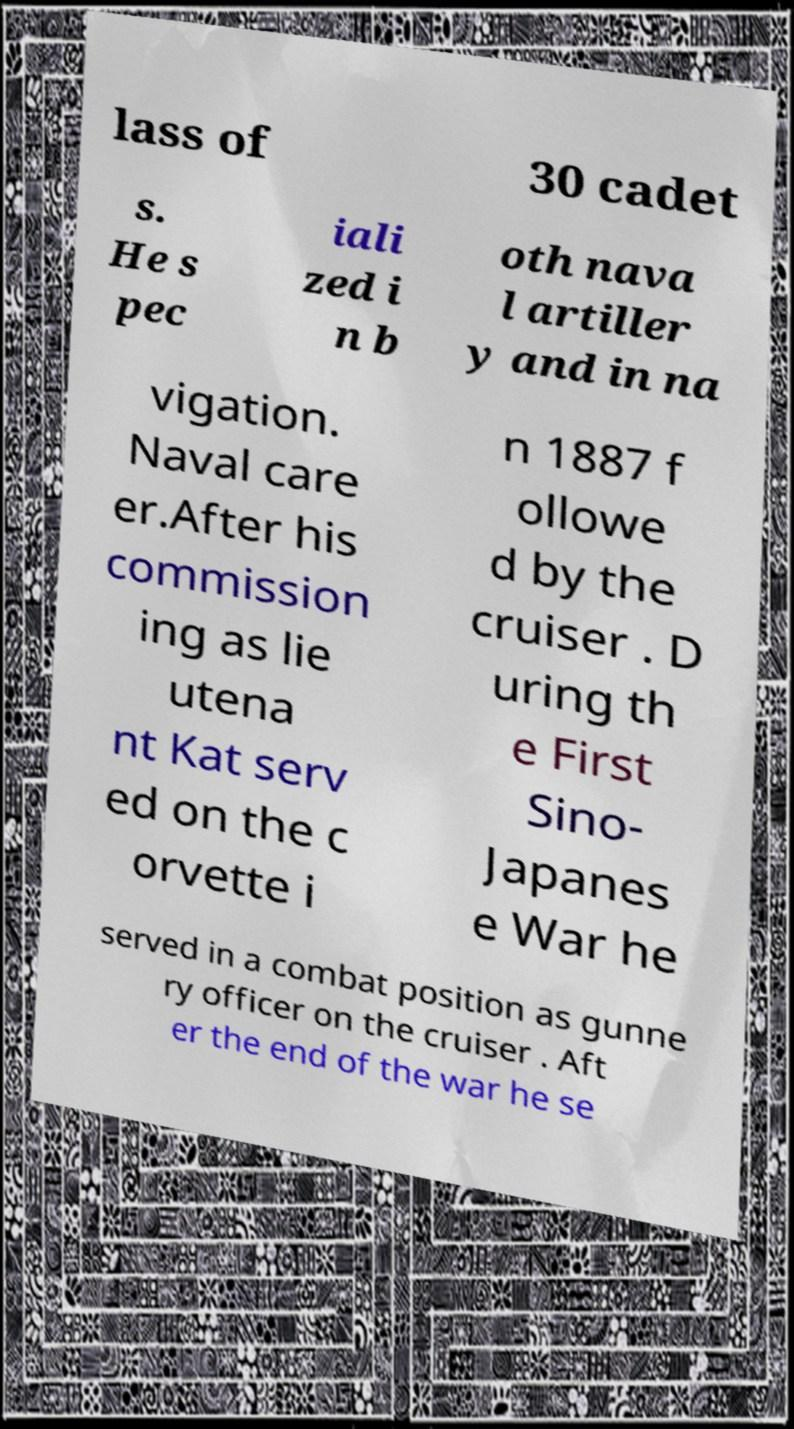Can you accurately transcribe the text from the provided image for me? lass of 30 cadet s. He s pec iali zed i n b oth nava l artiller y and in na vigation. Naval care er.After his commission ing as lie utena nt Kat serv ed on the c orvette i n 1887 f ollowe d by the cruiser . D uring th e First Sino- Japanes e War he served in a combat position as gunne ry officer on the cruiser . Aft er the end of the war he se 